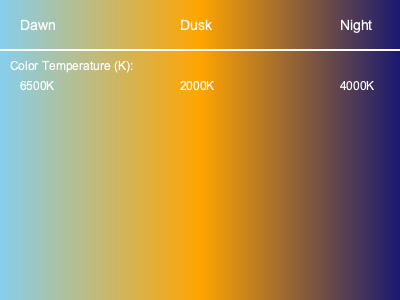Analyze the color palette transition in the day-night cycle diagram. What is the approximate color temperature (in Kelvin) at dusk, and how does this affect the overall mood and lighting of the game environment? To answer this question, let's break down the analysis step-by-step:

1. Examine the diagram:
   The image shows a color gradient representing the day-night cycle, with labels for Dawn, Dusk, and Night.

2. Locate the dusk section:
   The middle part of the gradient, labeled "Dusk," represents the transition between day and night.

3. Identify the color temperature at dusk:
   Directly below the "Dusk" label, we can see the color temperature value of 2000K.

4. Understand color temperature:
   Color temperature is measured in Kelvin (K). Lower values (2000-3000K) produce warmer, more orange-red light, while higher values (5000-6500K) produce cooler, more blue-white light.

5. Analyze the effect on mood and lighting:
   A color temperature of 2000K at dusk implies:
   a) Warm, golden-orange lighting
   b) Creates a cozy, intimate atmosphere
   c) Enhances the feeling of a setting sun
   d) Increases contrast between lit areas and shadows
   e) May limit visibility in darker areas of the game environment

6. Consider the impact on gameplay:
   The warm, low-light conditions at dusk can:
   a) Change how players perceive the environment
   b) Affect gameplay mechanics (e.g., stealth, visibility)
   c) Influence the emotional response of players

7. Compare to other times of day:
   Dawn (6500K) and Night (4000K) have different color temperatures, creating a dynamic lighting cycle that adds realism and variety to the game world.
Answer: 2000K; creates warm, golden lighting with increased contrast and limited visibility, enhancing mood and realism. 